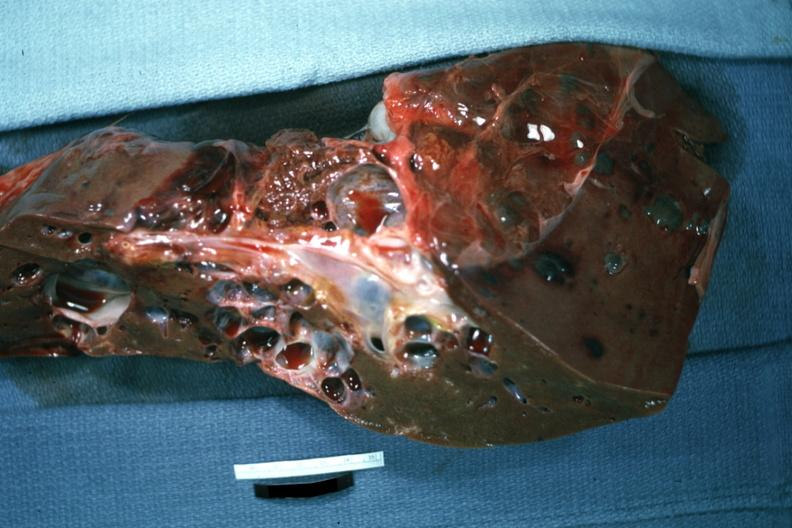what is present?
Answer the question using a single word or phrase. Hepatobiliary 